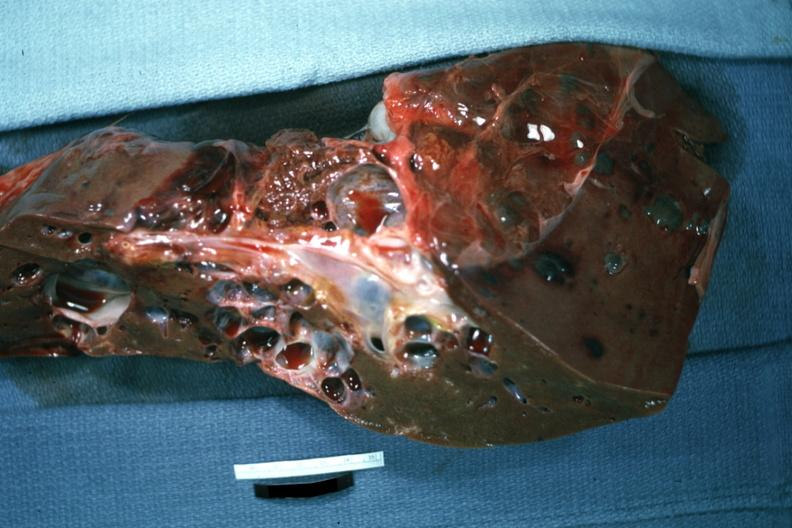what is present?
Answer the question using a single word or phrase. Hepatobiliary 